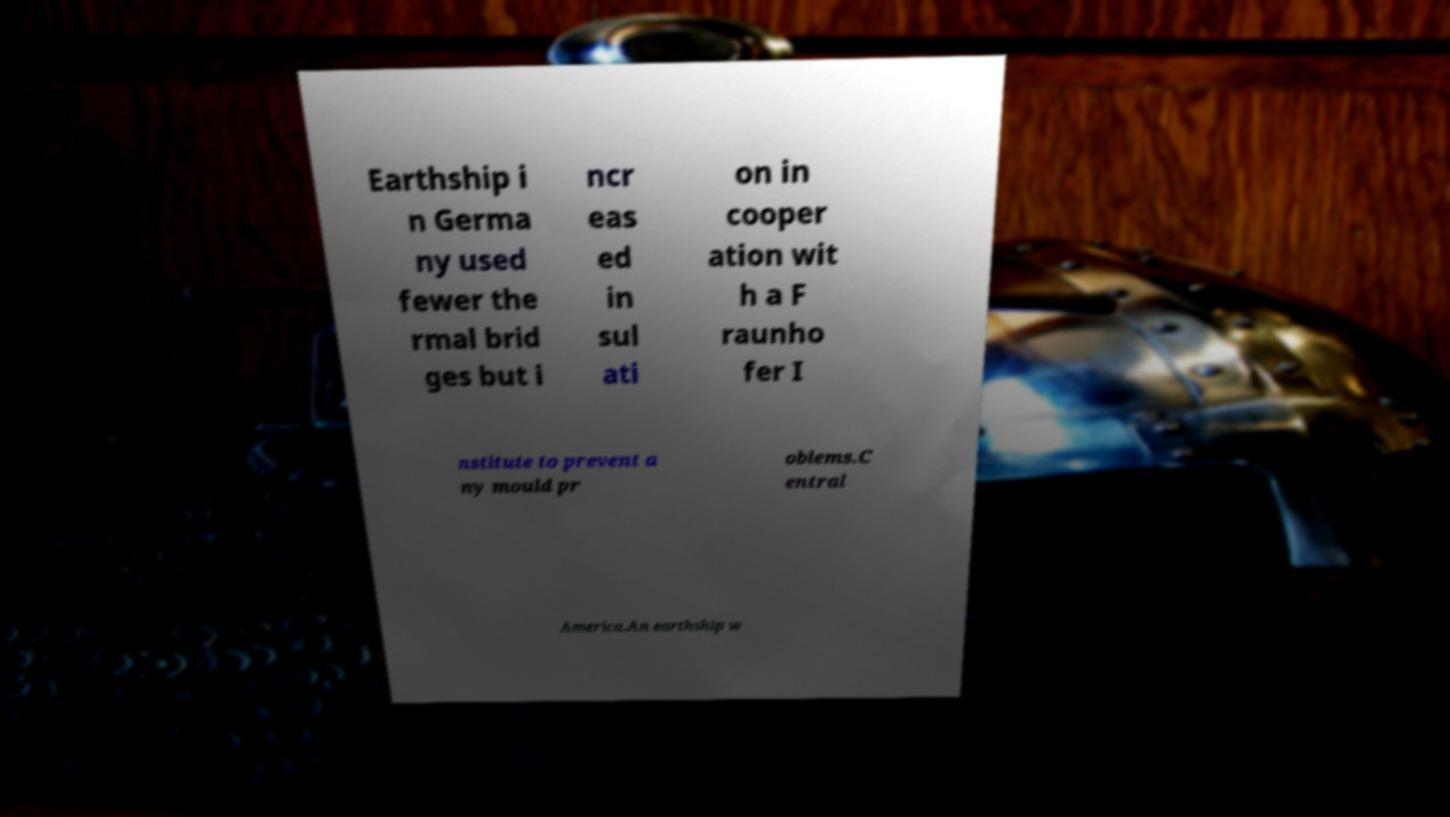Please read and relay the text visible in this image. What does it say? Earthship i n Germa ny used fewer the rmal brid ges but i ncr eas ed in sul ati on in cooper ation wit h a F raunho fer I nstitute to prevent a ny mould pr oblems.C entral America.An earthship w 